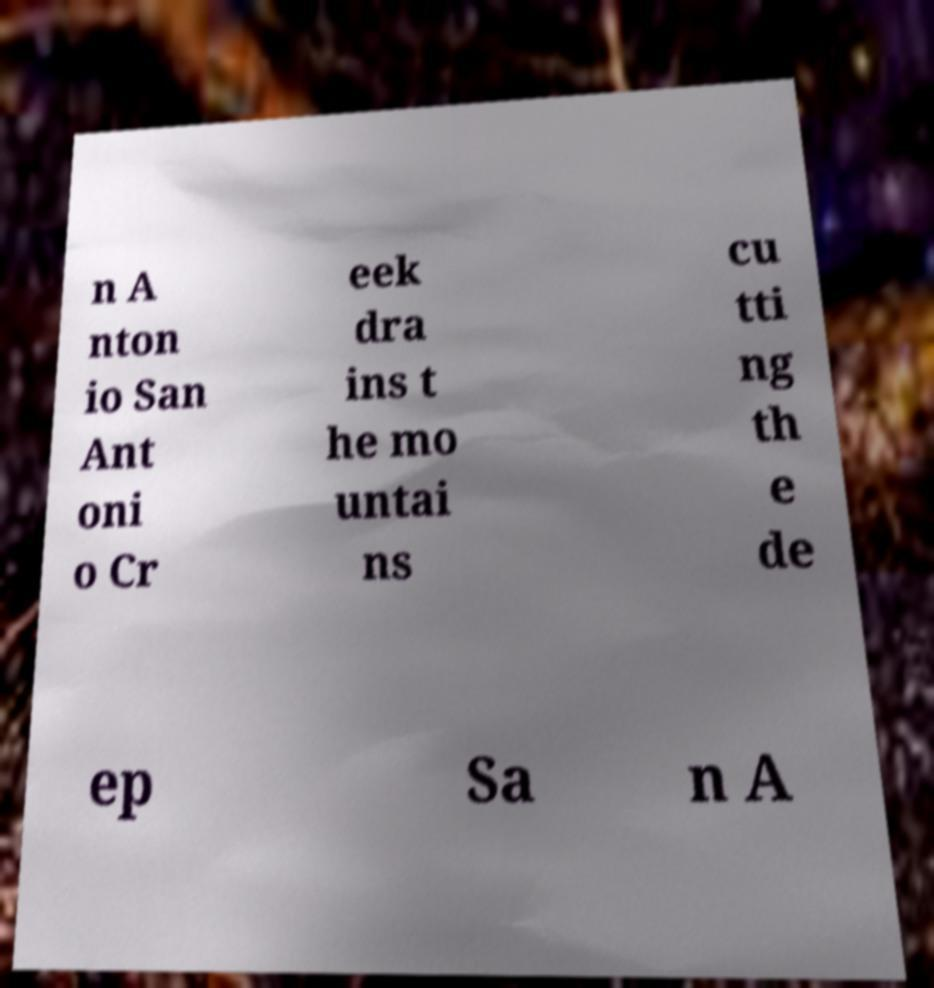What messages or text are displayed in this image? I need them in a readable, typed format. n A nton io San Ant oni o Cr eek dra ins t he mo untai ns cu tti ng th e de ep Sa n A 